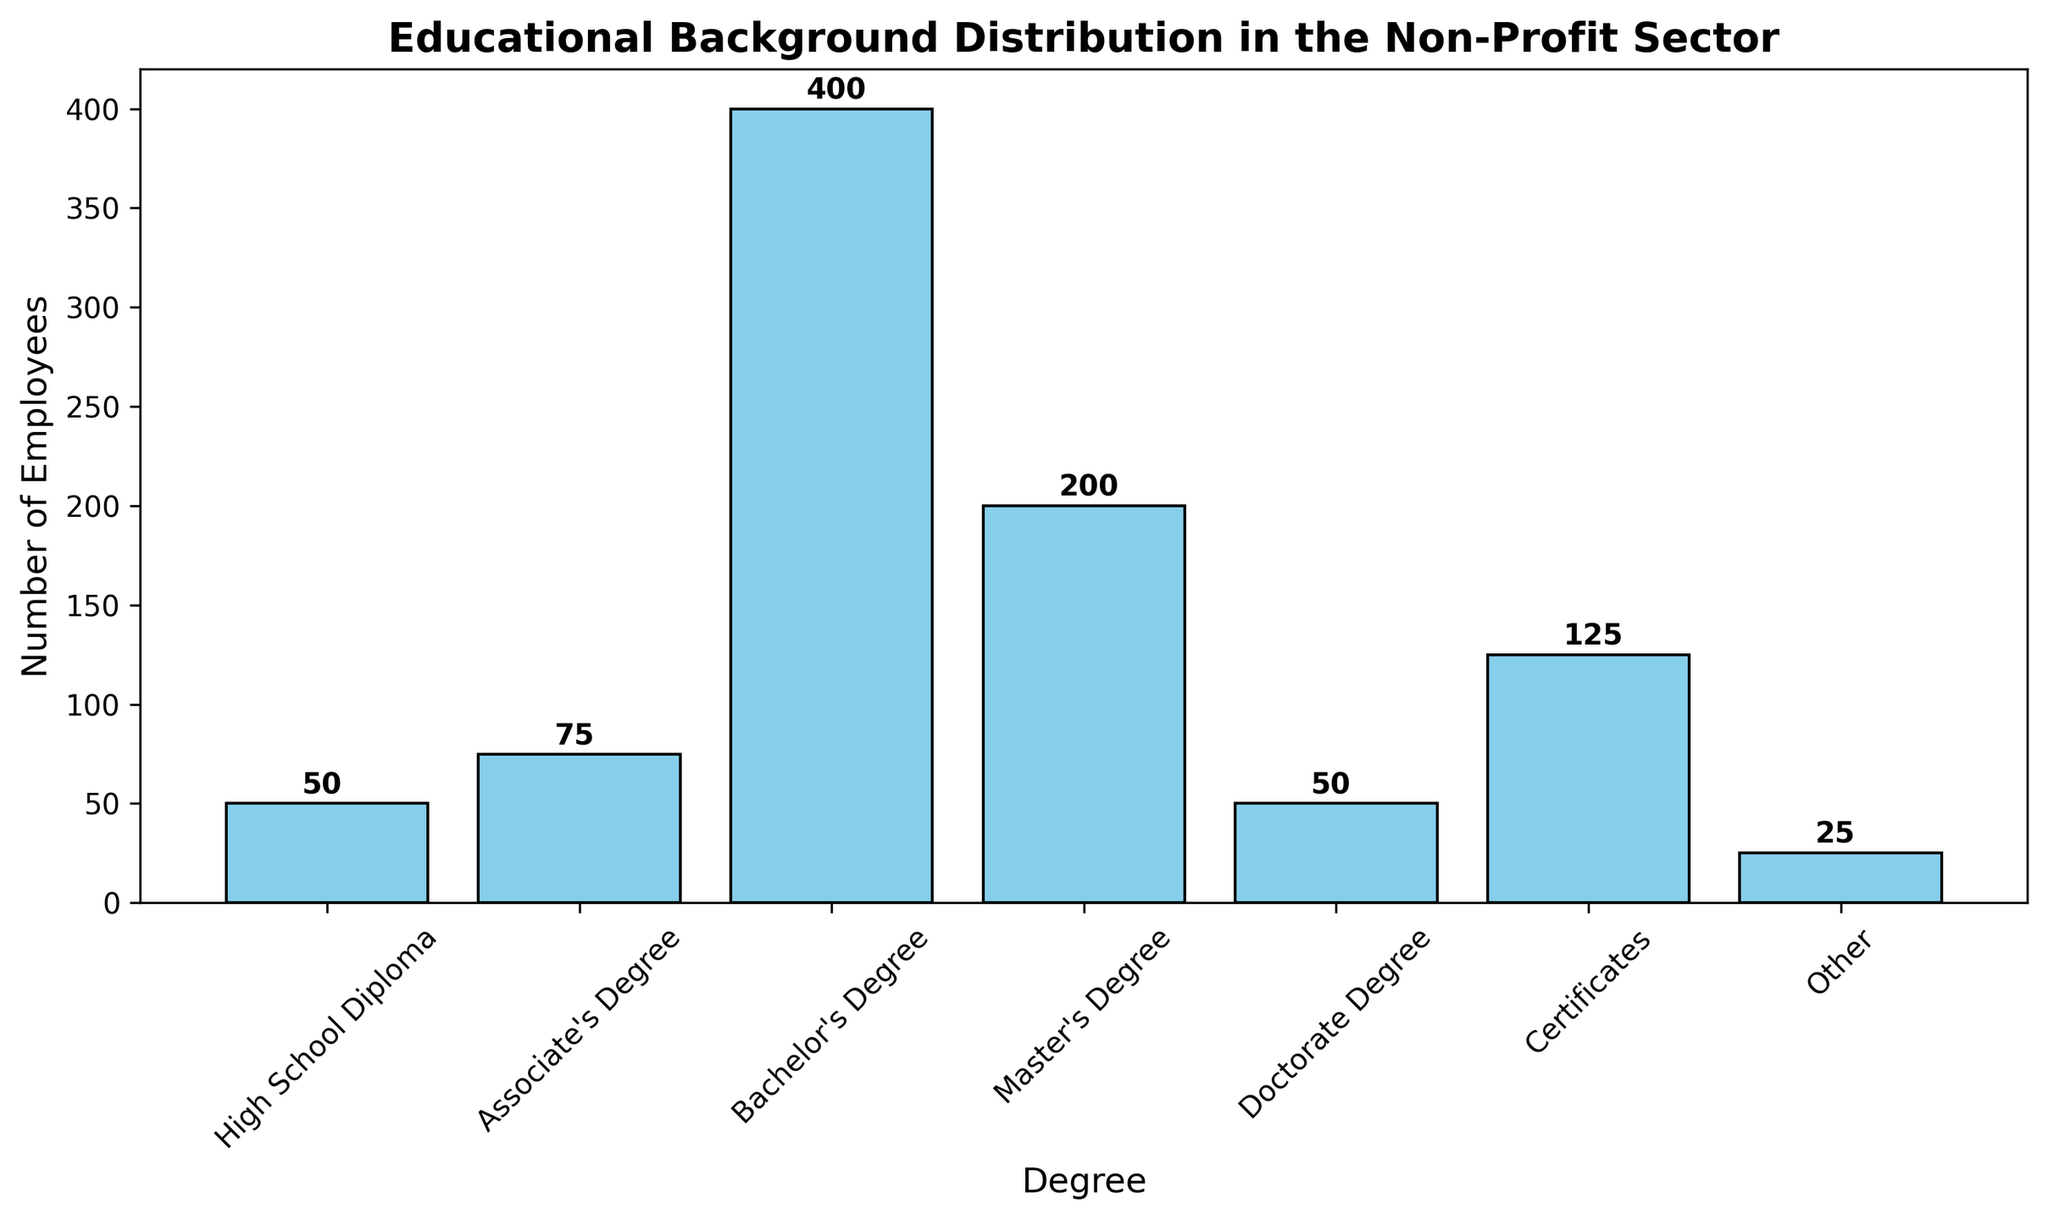What's the total number of employees with a Bachelor's Degree or higher? Sum the number of employees for Bachelor's Degree (400), Master's Degree (200), and Doctorate Degree (50): 400 + 200 + 50 = 650.
Answer: 650 Which degree has the highest number of employees? The bar representing the Bachelor's Degree is the tallest, indicating it has the highest number of employees at 400.
Answer: Bachelor's Degree How many more employees have an Associate's Degree compared to a High School Diploma? Subtract the number of employees with a High School Diploma (50) from those with an Associate's Degree (75): 75 - 50 = 25.
Answer: 25 Which degree category has the smallest number of employees? The bar for "Other" is the shortest, indicating it has the smallest number of employees at 25.
Answer: Other What's the difference in the number of employees between those with Master's Degrees and Certificates? Subtract the number of employees with Certificates (125) from those with a Master's Degree (200): 200 - 125 = 75.
Answer: 75 If you group the degrees into "Higher Education" (Bachelor's, Master's, Doctorate) and "Non-Higher Education" (the rest), which group has more employees and by how much? Sum the employees in the "Higher Education" group: 400 + 200 + 50 = 650. Sum the employees in the "Non-Higher Education" group: 50 + 75 + 125 + 25 = 275. The difference is 650 - 275 = 375.
Answer: Higher Education by 375 What is the average number of employees across all degree categories? Sum the number of employees in all categories (50 + 75 + 400 + 200 + 50 + 125 + 25 = 925) and divide by the number of categories (7): 925 / 7 ≈ 132.14.
Answer: 132.14 Which degree categories have an equal number of employees? The High School Diploma and Doctorate Degree categories both have 50 employees.
Answer: High School Diploma and Doctorate Degree 